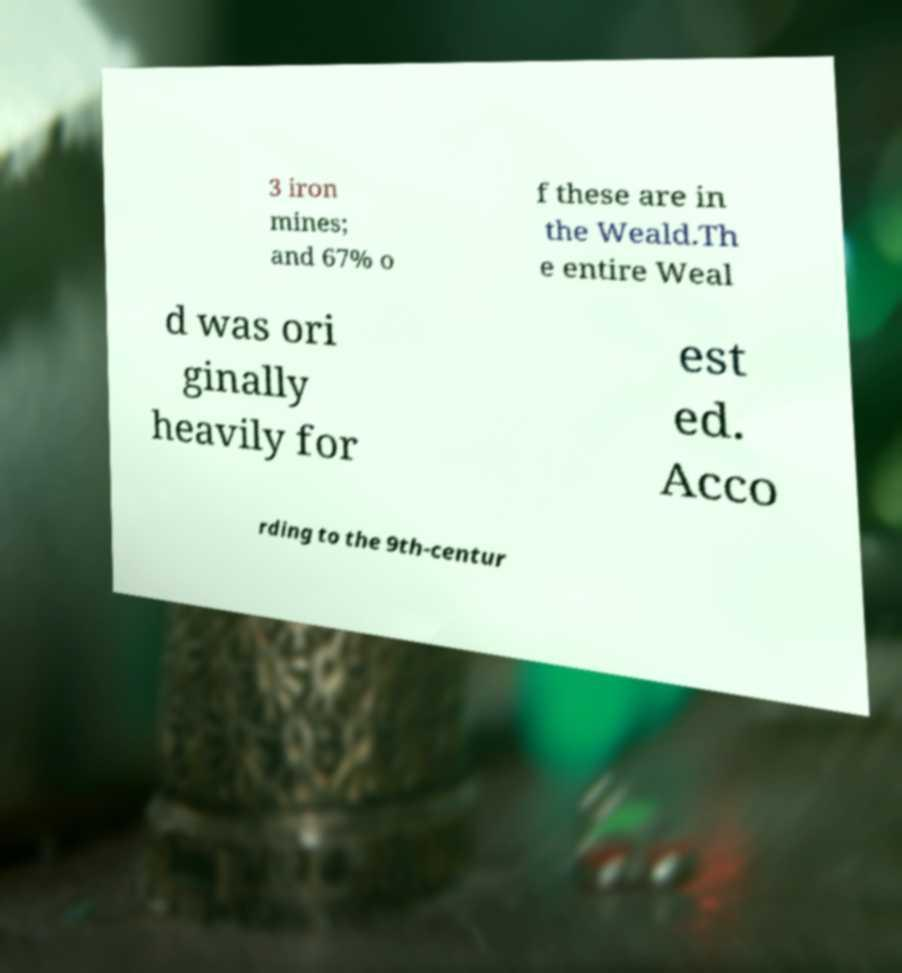There's text embedded in this image that I need extracted. Can you transcribe it verbatim? 3 iron mines; and 67% o f these are in the Weald.Th e entire Weal d was ori ginally heavily for est ed. Acco rding to the 9th-centur 